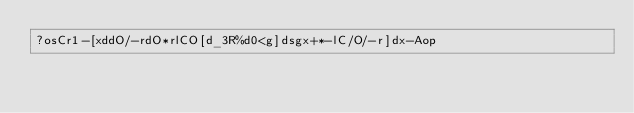<code> <loc_0><loc_0><loc_500><loc_500><_dc_>?osCr1-[xddO/-rdO*rlCO[d_3R%d0<g]dsgx+*-lC/O/-r]dx-Aop</code> 